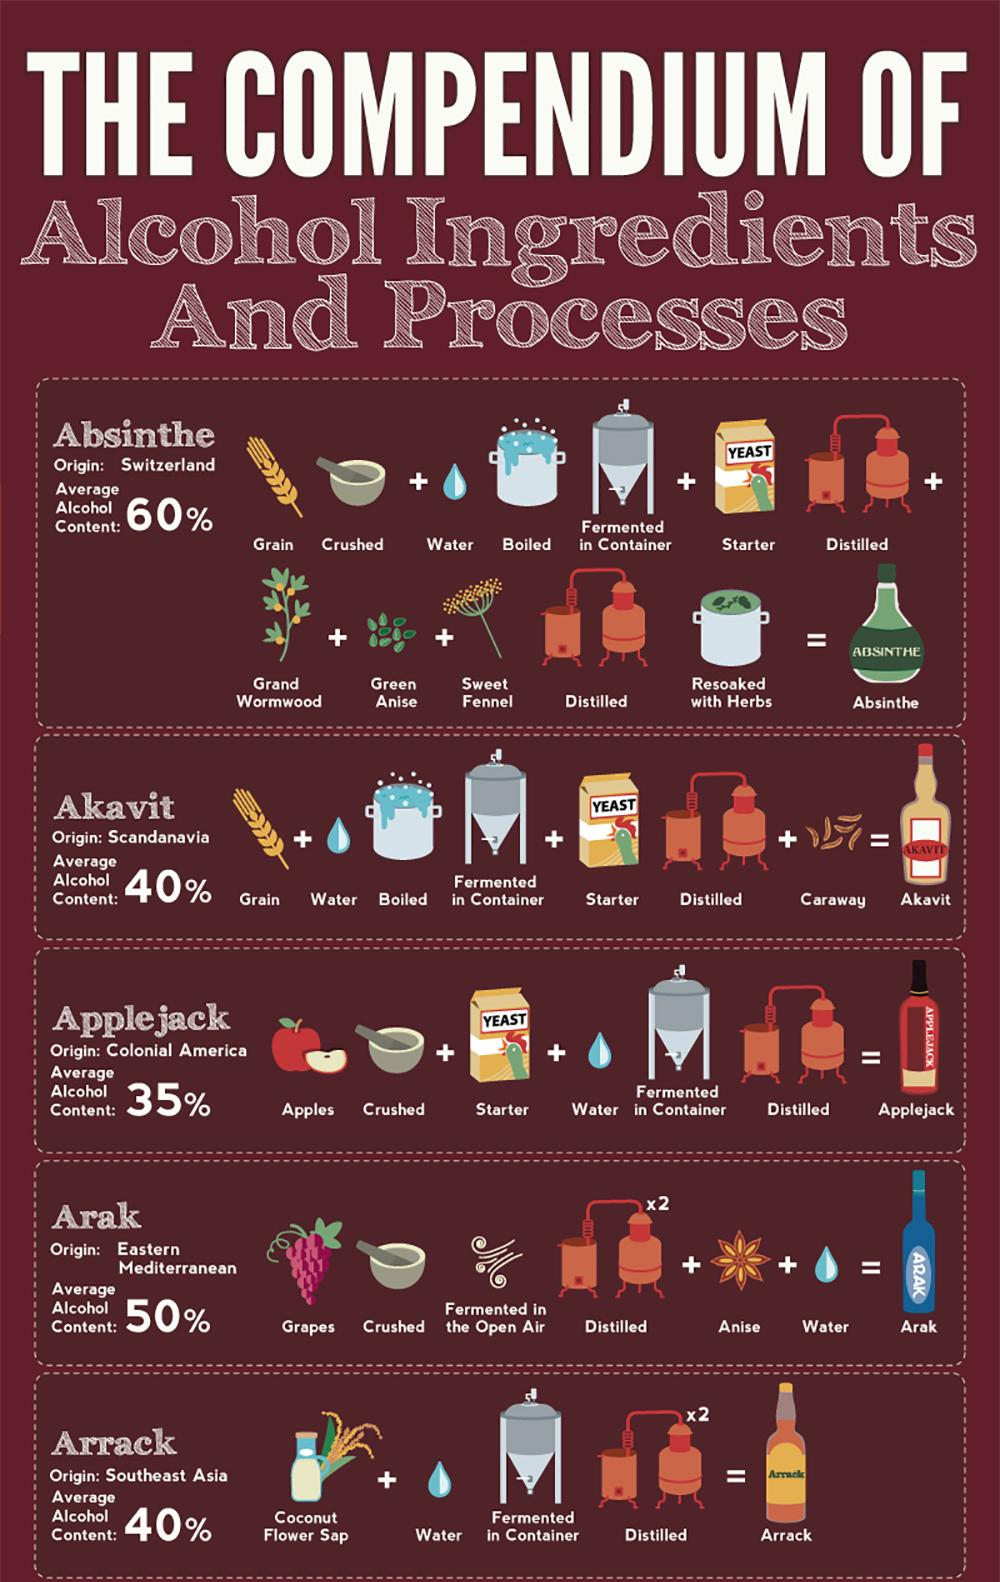Give some essential details in this illustration. Arrack is made primarily from the sap of coconut flowers. The production of Applejack involves three processes. The process of making Absinthe involves approximately 5 steps. Akavit is produced through the involvement of three processes. Anise is an ingredient in the variety of alcohol known as arak. 